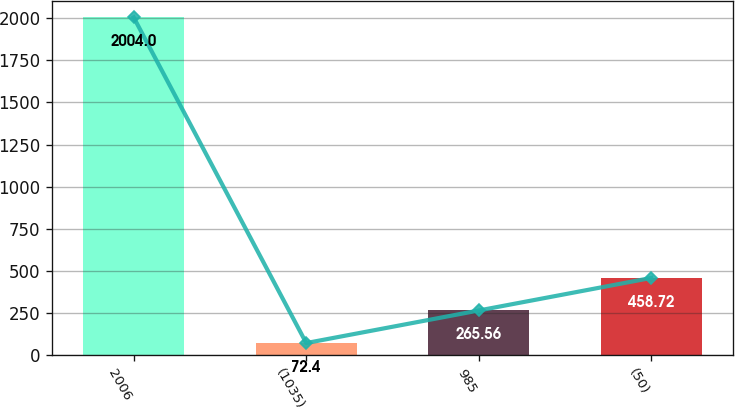Convert chart. <chart><loc_0><loc_0><loc_500><loc_500><bar_chart><fcel>2006<fcel>(1035)<fcel>985<fcel>(50)<nl><fcel>2004<fcel>72.4<fcel>265.56<fcel>458.72<nl></chart> 